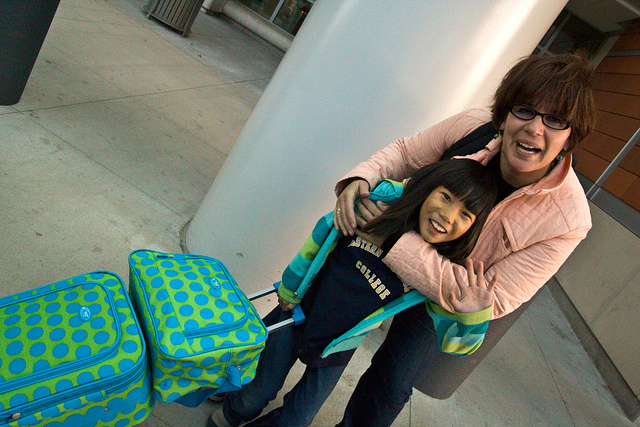Can you describe the luggage style and what it might say about the owner's preferences? The luggage in the image has a bright and playful polka-dot design, which suggests a preference for vibrant and eye-catching accessories. This choice might indicate that the owner, likely the young girl, enjoys fun and distinctive designs that stand out, making it easier to spot her luggage on a carousel or in a crowd. 